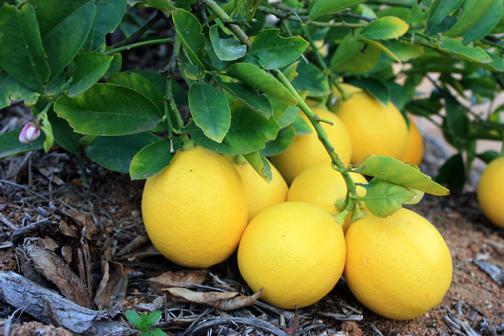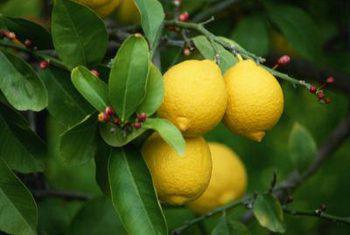The first image is the image on the left, the second image is the image on the right. Given the left and right images, does the statement "One image contains only two whole lemons with peels intact." hold true? Answer yes or no. No. The first image is the image on the left, the second image is the image on the right. Considering the images on both sides, is "The right image contains no more than three lemons." valid? Answer yes or no. No. 